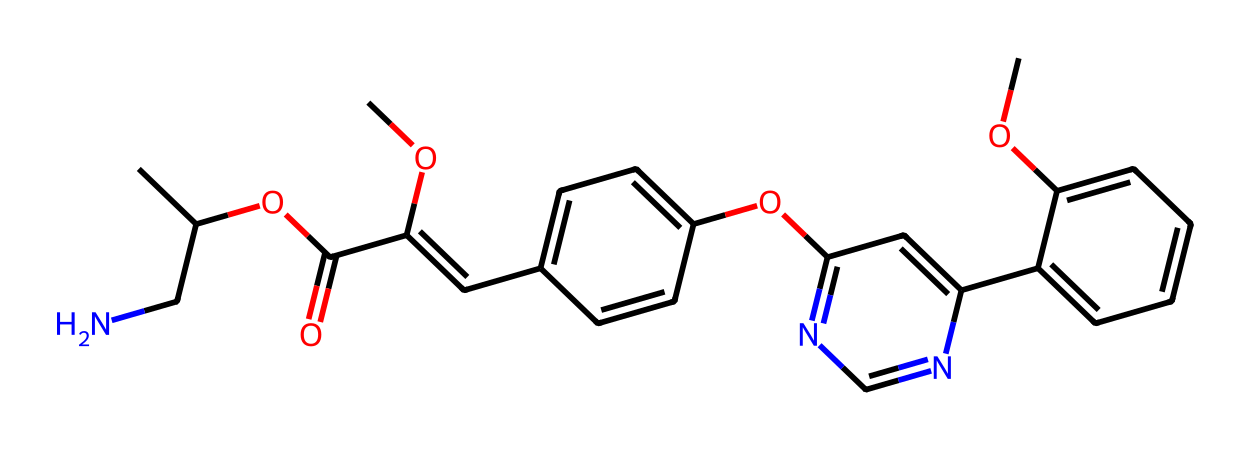What is the molecular formula of azoxystrobin? To find the molecular formula, we need to identify the number of each type of atom in the chemical structure. Counting the atoms in the SMILES representation leads to C16H18N4O5.
Answer: C16H18N4O5 How many rings are present in the azoxystrobin structure? By examining the chemical structure, we can identify the rings formed by the bonds. The structure contains 3 distinct rings.
Answer: 3 What functional groups can be identified in azoxystrobin? Analysis of the structure reveals the presence of multiple functional groups such as esters and ethers. Specifically, there are two ester functional groups and ether groups in the compound.
Answer: esters and ethers How many nitrogen atoms are in azoxystrobin? By counting directly from the chemical structure, we determine that there are 4 nitrogen atoms.
Answer: 4 What is the primary use of azoxystrobin? The chemical structure suggests that azoxystrobin is primarily used as a fungicide, able to prevent or treat fungal infections in plants.
Answer: fungicide Which part of azoxystrobin is likely responsible for its antifungal activity? The structure includes a portion known as the strobilurin group, characterized by specific molecular arrangements conducive to disrupting fungal cell respiration, which is critical for its antifungal properties.
Answer: strobilurin group What environmental concerns might arise from the use of azoxystrobin? The use of azoxystrobin can raise environmental concerns related to its persistence in soils and potential to affect non-target organisms, leading to discussions in local environmental policy.
Answer: environmental concerns 